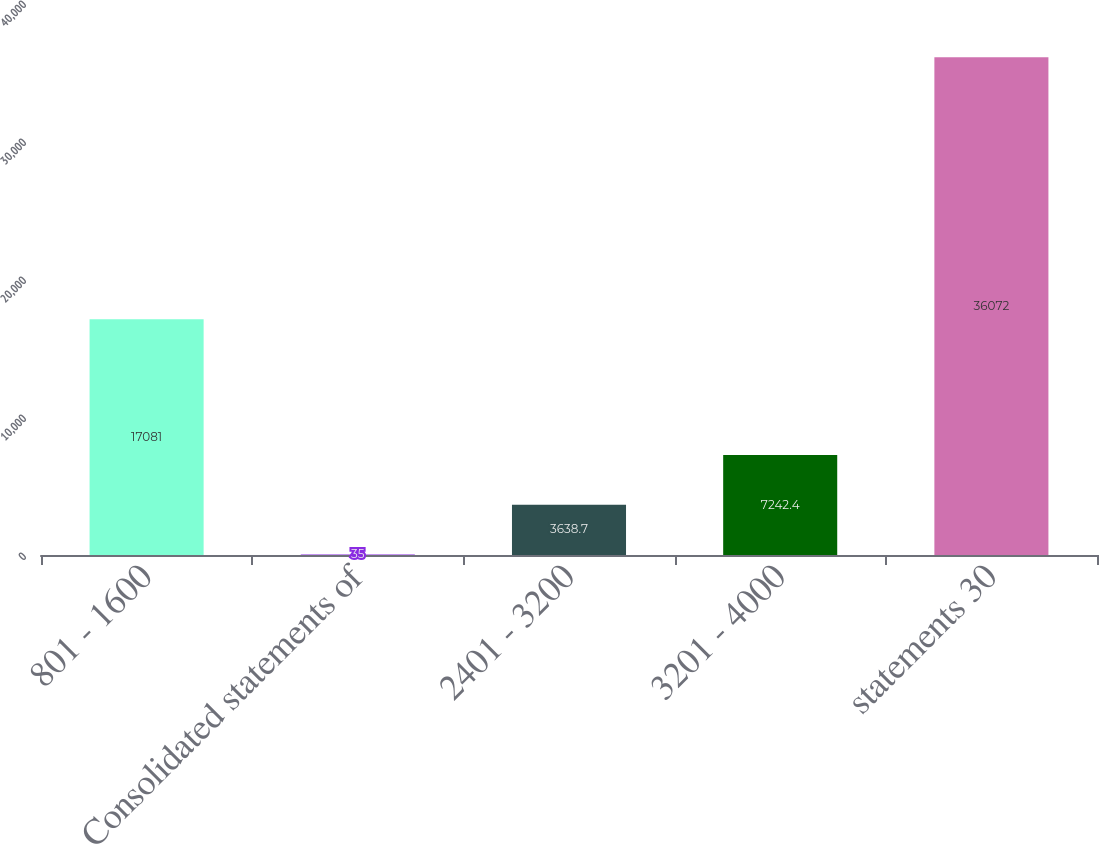<chart> <loc_0><loc_0><loc_500><loc_500><bar_chart><fcel>801 - 1600<fcel>Consolidated statements of<fcel>2401 - 3200<fcel>3201 - 4000<fcel>statements 30<nl><fcel>17081<fcel>35<fcel>3638.7<fcel>7242.4<fcel>36072<nl></chart> 